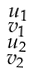Convert formula to latex. <formula><loc_0><loc_0><loc_500><loc_500>\begin{smallmatrix} u _ { 1 } \\ v _ { 1 } \\ u _ { 2 } \\ v _ { 2 } \end{smallmatrix}</formula> 